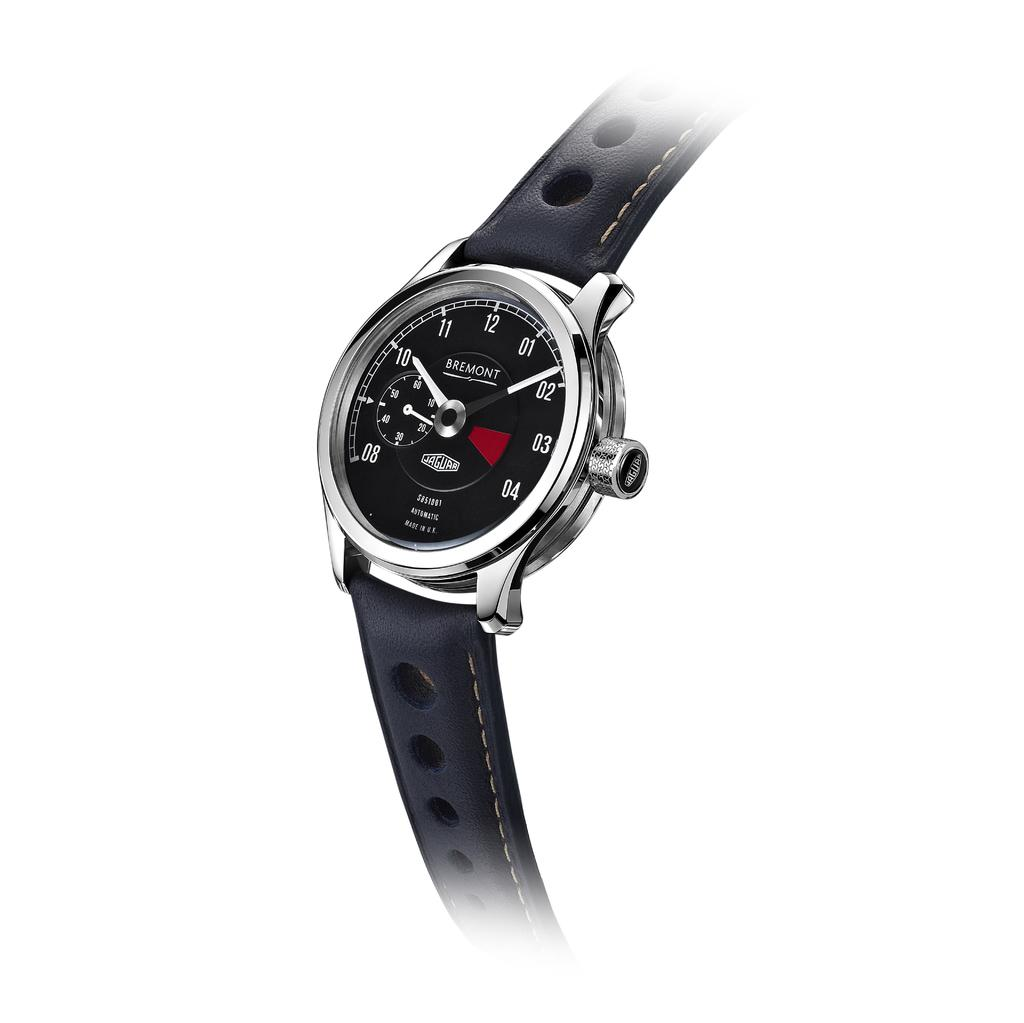<image>
Create a compact narrative representing the image presented. the word Bremont that is on a watch 